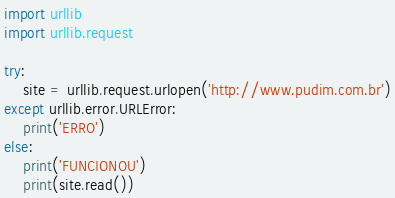<code> <loc_0><loc_0><loc_500><loc_500><_Python_>import urllib
import urllib.request

try:
    site = urllib.request.urlopen('http://www.pudim.com.br')
except urllib.error.URLError:
    print('ERRO')
else:
    print('FUNCIONOU')
    print(site.read())
</code> 